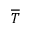<formula> <loc_0><loc_0><loc_500><loc_500>\overline { T }</formula> 